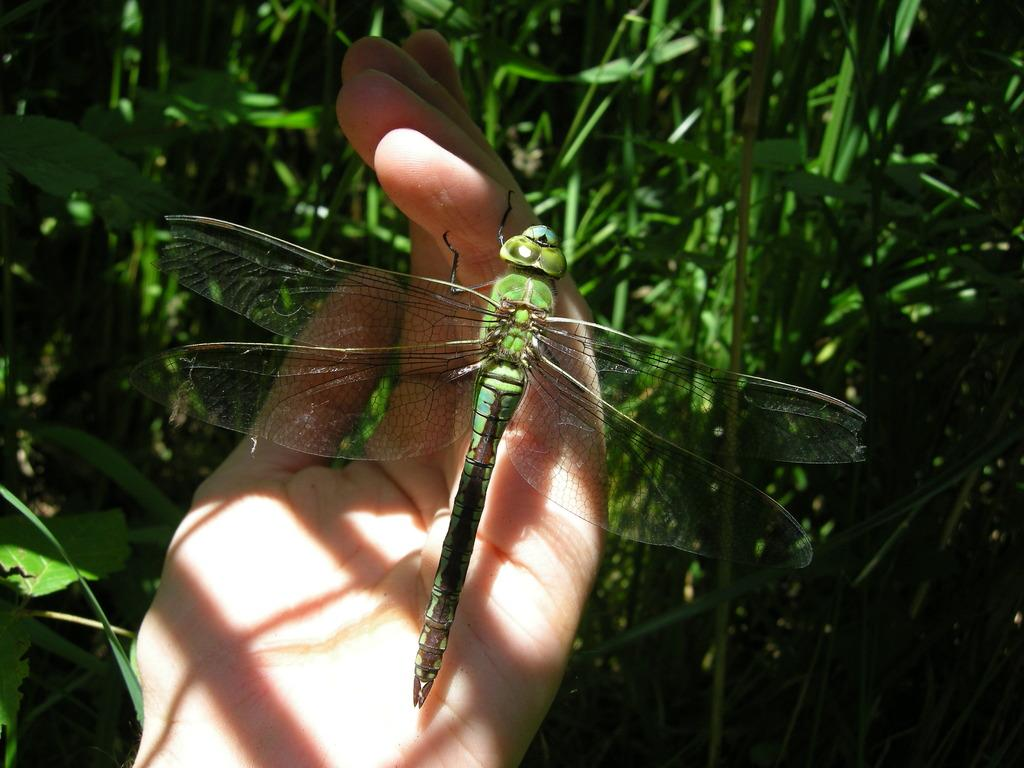What part of a person is visible in the image? There is a hand of a person in the image. What is on the hand in the image? There is a flying insect on the hand. What type of vegetation can be seen in the background of the image? There is green grass in the background of the image. What decision did the representative make regarding their friend in the image? There is no representative or friend present in the image, so it is not possible to answer that question. 